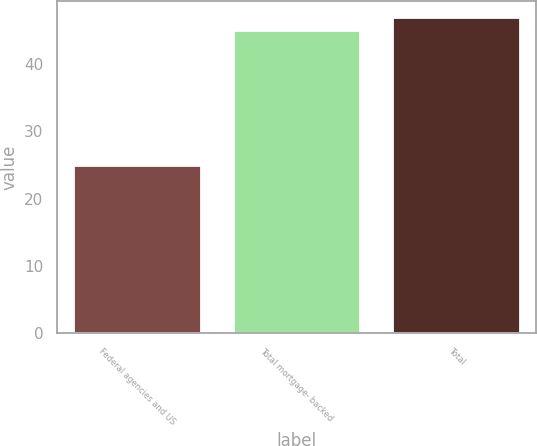Convert chart to OTSL. <chart><loc_0><loc_0><loc_500><loc_500><bar_chart><fcel>Federal agencies and US<fcel>Total mortgage- backed<fcel>Total<nl><fcel>25<fcel>45<fcel>47<nl></chart> 